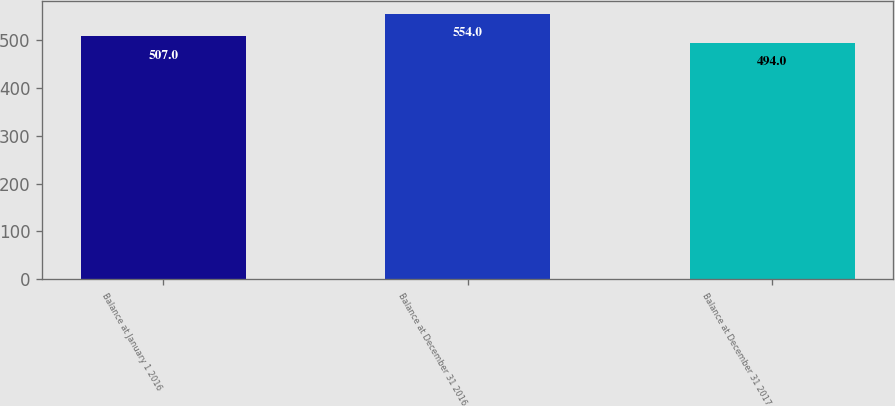<chart> <loc_0><loc_0><loc_500><loc_500><bar_chart><fcel>Balance at January 1 2016<fcel>Balance at December 31 2016<fcel>Balance at December 31 2017<nl><fcel>507<fcel>554<fcel>494<nl></chart> 